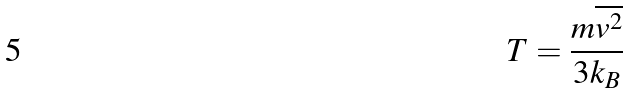Convert formula to latex. <formula><loc_0><loc_0><loc_500><loc_500>T = \frac { m \overline { v ^ { 2 } } } { 3 k _ { B } }</formula> 